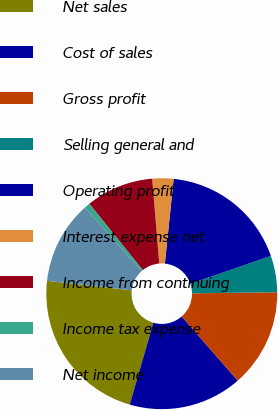Convert chart to OTSL. <chart><loc_0><loc_0><loc_500><loc_500><pie_chart><fcel>Net sales<fcel>Cost of sales<fcel>Gross profit<fcel>Selling general and<fcel>Operating profit<fcel>Interest expense net<fcel>Income from continuing<fcel>Income tax expense<fcel>Net income<nl><fcel>22.3%<fcel>15.91%<fcel>13.77%<fcel>5.11%<fcel>18.06%<fcel>2.96%<fcel>9.47%<fcel>0.81%<fcel>11.62%<nl></chart> 